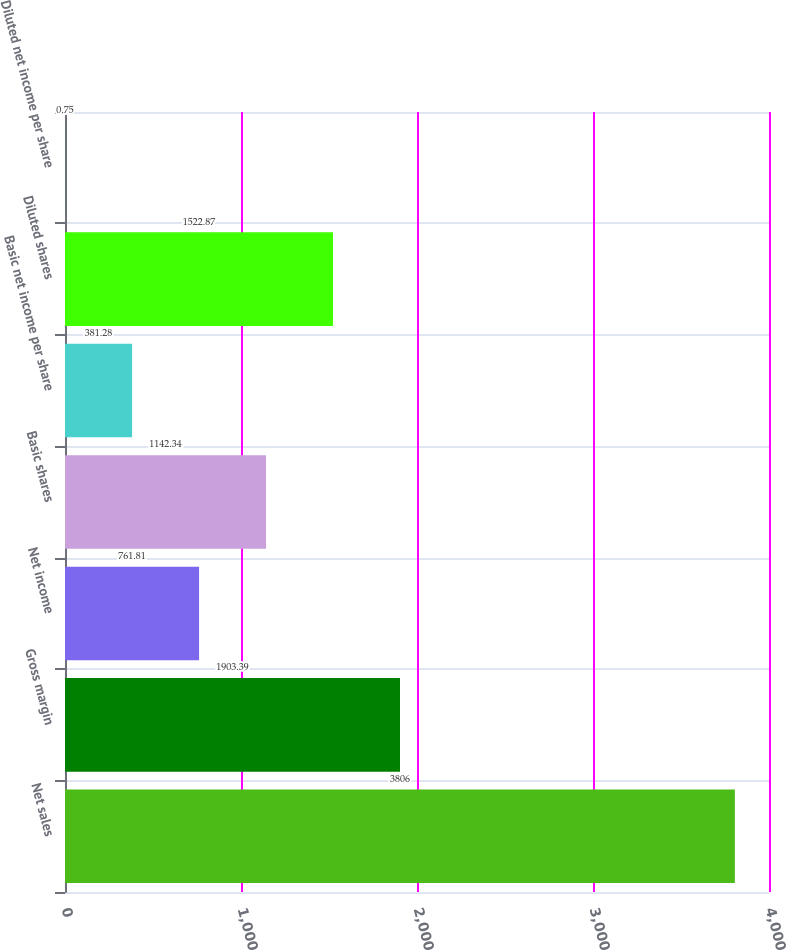Convert chart. <chart><loc_0><loc_0><loc_500><loc_500><bar_chart><fcel>Net sales<fcel>Gross margin<fcel>Net income<fcel>Basic shares<fcel>Basic net income per share<fcel>Diluted shares<fcel>Diluted net income per share<nl><fcel>3806<fcel>1903.39<fcel>761.81<fcel>1142.34<fcel>381.28<fcel>1522.87<fcel>0.75<nl></chart> 